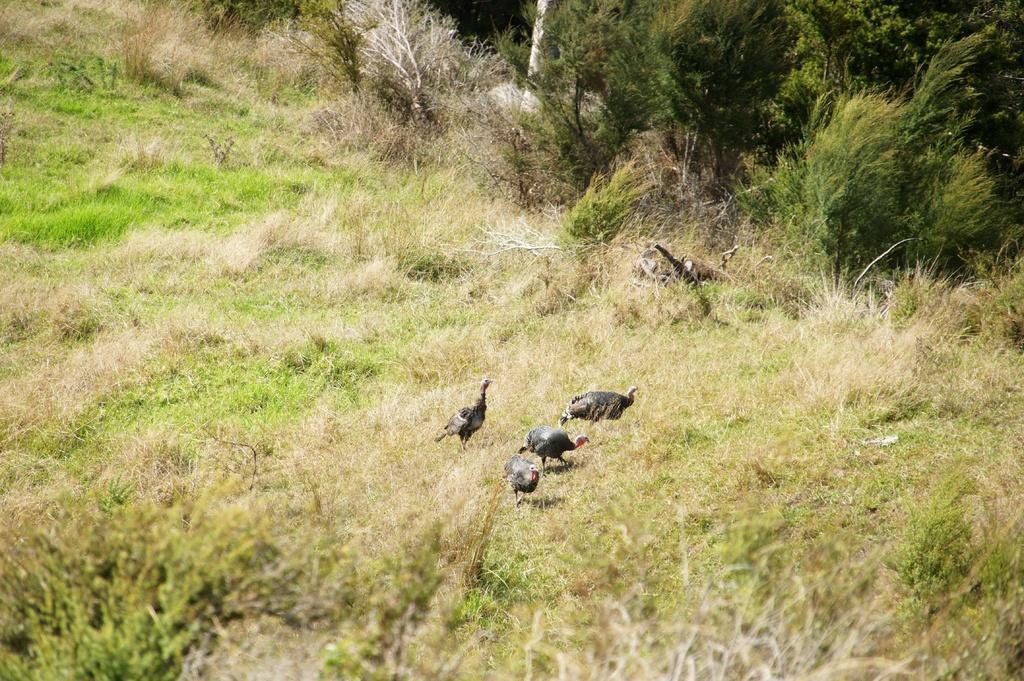Describe this image in one or two sentences. In the image there are few birds walking on the grassland and in the back there are trees. 